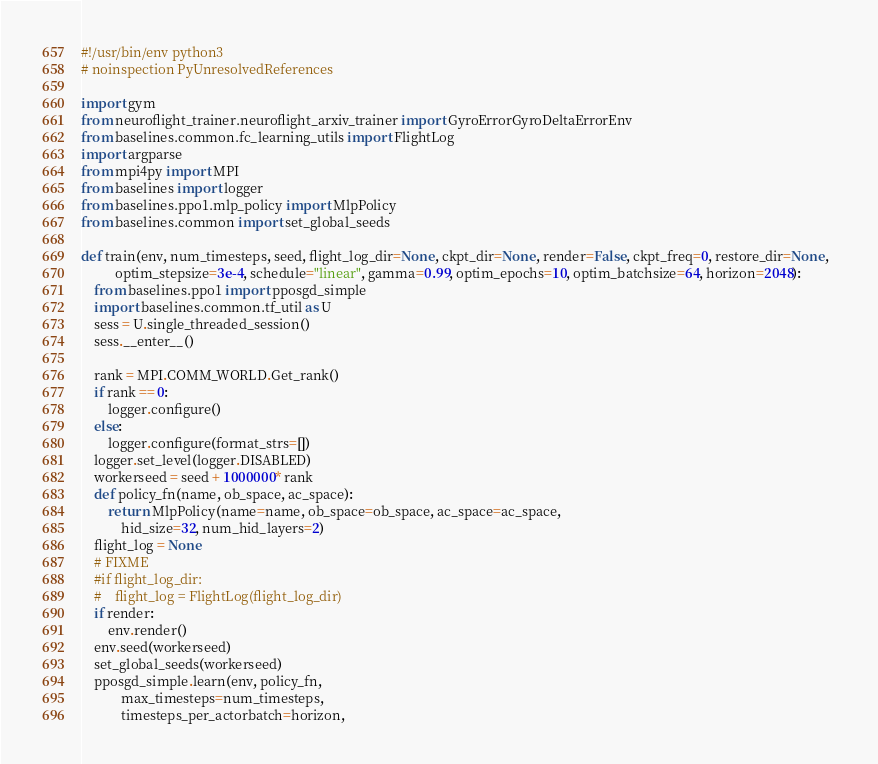Convert code to text. <code><loc_0><loc_0><loc_500><loc_500><_Python_>#!/usr/bin/env python3
# noinspection PyUnresolvedReferences

import gym
from neuroflight_trainer.neuroflight_arxiv_trainer import GyroErrorGyroDeltaErrorEnv
from baselines.common.fc_learning_utils import FlightLog
import argparse
from mpi4py import MPI
from baselines import logger
from baselines.ppo1.mlp_policy import MlpPolicy
from baselines.common import set_global_seeds

def train(env, num_timesteps, seed, flight_log_dir=None, ckpt_dir=None, render=False, ckpt_freq=0, restore_dir=None,  
          optim_stepsize=3e-4, schedule="linear", gamma=0.99, optim_epochs=10, optim_batchsize=64, horizon=2048):
    from baselines.ppo1 import pposgd_simple
    import baselines.common.tf_util as U
    sess = U.single_threaded_session()
    sess.__enter__()

    rank = MPI.COMM_WORLD.Get_rank()
    if rank == 0:
        logger.configure()
    else:
        logger.configure(format_strs=[])
    logger.set_level(logger.DISABLED)
    workerseed = seed + 1000000 * rank
    def policy_fn(name, ob_space, ac_space):
        return MlpPolicy(name=name, ob_space=ob_space, ac_space=ac_space,
            hid_size=32, num_hid_layers=2)
    flight_log = None
    # FIXME
    #if flight_log_dir:
    #    flight_log = FlightLog(flight_log_dir)
    if render:
        env.render()
    env.seed(workerseed)
    set_global_seeds(workerseed)
    pposgd_simple.learn(env, policy_fn,
            max_timesteps=num_timesteps,
            timesteps_per_actorbatch=horizon,</code> 